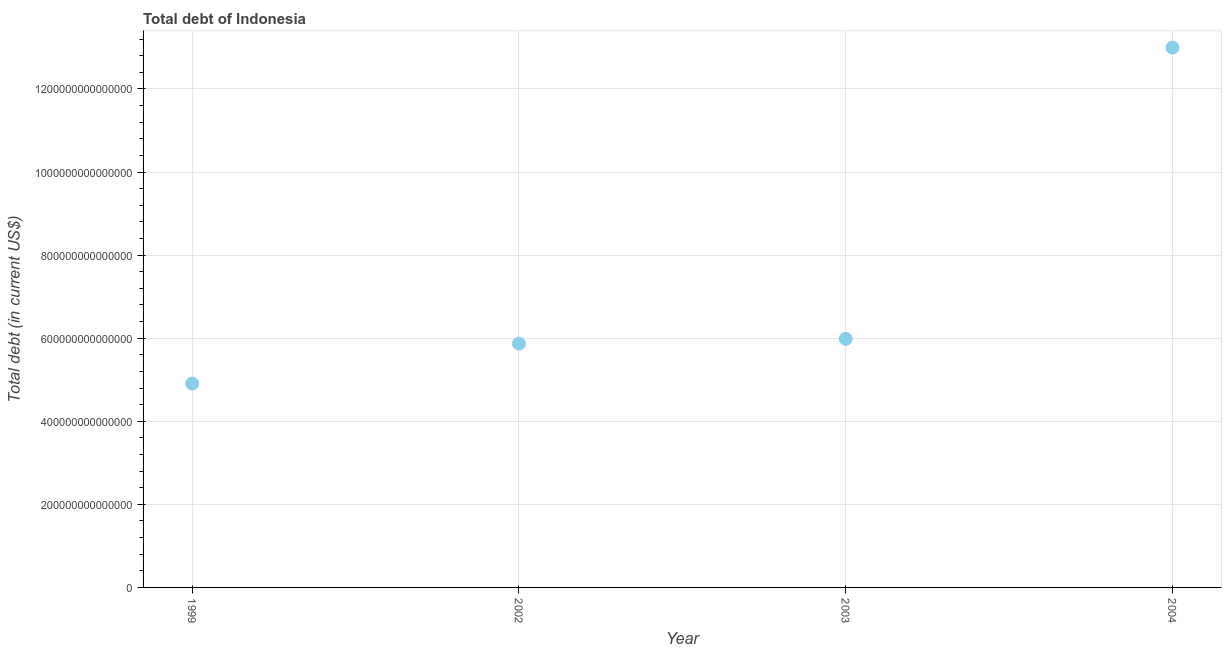What is the total debt in 2002?
Your answer should be very brief. 5.87e+14. Across all years, what is the maximum total debt?
Make the answer very short. 1.30e+15. Across all years, what is the minimum total debt?
Provide a short and direct response. 4.91e+14. In which year was the total debt maximum?
Offer a very short reply. 2004. In which year was the total debt minimum?
Provide a succinct answer. 1999. What is the sum of the total debt?
Ensure brevity in your answer.  2.98e+15. What is the difference between the total debt in 2002 and 2003?
Provide a short and direct response. -1.13e+13. What is the average total debt per year?
Provide a short and direct response. 7.44e+14. What is the median total debt?
Offer a very short reply. 5.93e+14. What is the ratio of the total debt in 2002 to that in 2003?
Your answer should be compact. 0.98. Is the total debt in 2003 less than that in 2004?
Give a very brief answer. Yes. What is the difference between the highest and the second highest total debt?
Ensure brevity in your answer.  7.01e+14. Is the sum of the total debt in 1999 and 2004 greater than the maximum total debt across all years?
Your answer should be very brief. Yes. What is the difference between the highest and the lowest total debt?
Offer a terse response. 8.09e+14. In how many years, is the total debt greater than the average total debt taken over all years?
Keep it short and to the point. 1. How many years are there in the graph?
Give a very brief answer. 4. What is the difference between two consecutive major ticks on the Y-axis?
Provide a short and direct response. 2.00e+14. Are the values on the major ticks of Y-axis written in scientific E-notation?
Provide a short and direct response. No. Does the graph contain grids?
Provide a succinct answer. Yes. What is the title of the graph?
Your answer should be very brief. Total debt of Indonesia. What is the label or title of the X-axis?
Your answer should be very brief. Year. What is the label or title of the Y-axis?
Your answer should be very brief. Total debt (in current US$). What is the Total debt (in current US$) in 1999?
Give a very brief answer. 4.91e+14. What is the Total debt (in current US$) in 2002?
Your answer should be compact. 5.87e+14. What is the Total debt (in current US$) in 2003?
Make the answer very short. 5.98e+14. What is the Total debt (in current US$) in 2004?
Ensure brevity in your answer.  1.30e+15. What is the difference between the Total debt (in current US$) in 1999 and 2002?
Offer a very short reply. -9.64e+13. What is the difference between the Total debt (in current US$) in 1999 and 2003?
Offer a terse response. -1.08e+14. What is the difference between the Total debt (in current US$) in 1999 and 2004?
Offer a terse response. -8.09e+14. What is the difference between the Total debt (in current US$) in 2002 and 2003?
Ensure brevity in your answer.  -1.13e+13. What is the difference between the Total debt (in current US$) in 2002 and 2004?
Keep it short and to the point. -7.12e+14. What is the difference between the Total debt (in current US$) in 2003 and 2004?
Your response must be concise. -7.01e+14. What is the ratio of the Total debt (in current US$) in 1999 to that in 2002?
Give a very brief answer. 0.84. What is the ratio of the Total debt (in current US$) in 1999 to that in 2003?
Provide a short and direct response. 0.82. What is the ratio of the Total debt (in current US$) in 1999 to that in 2004?
Provide a short and direct response. 0.38. What is the ratio of the Total debt (in current US$) in 2002 to that in 2004?
Your answer should be very brief. 0.45. What is the ratio of the Total debt (in current US$) in 2003 to that in 2004?
Your answer should be very brief. 0.46. 